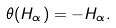<formula> <loc_0><loc_0><loc_500><loc_500>\theta ( H _ { \alpha } ) = - H _ { \alpha } .</formula> 